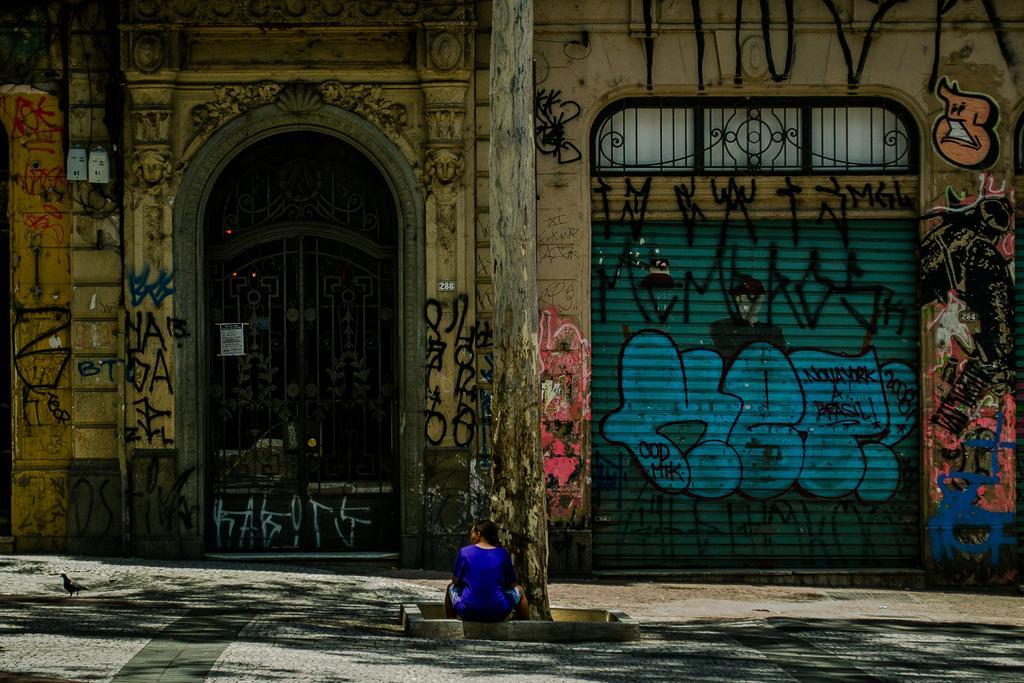Can you describe this image briefly? In this image I can see the person sitting on the rock. And the person is wearing the blue color dress. In-front of the person I can see the branch of the tree and also the building which is colorful. 